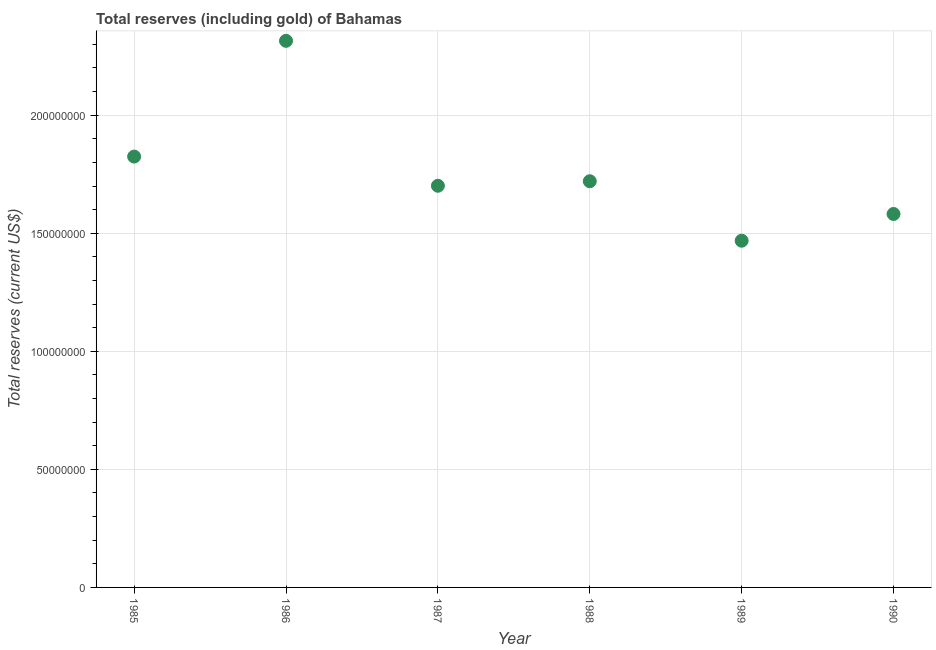What is the total reserves (including gold) in 1985?
Provide a short and direct response. 1.82e+08. Across all years, what is the maximum total reserves (including gold)?
Offer a terse response. 2.31e+08. Across all years, what is the minimum total reserves (including gold)?
Make the answer very short. 1.47e+08. In which year was the total reserves (including gold) maximum?
Give a very brief answer. 1986. In which year was the total reserves (including gold) minimum?
Your answer should be very brief. 1989. What is the sum of the total reserves (including gold)?
Your response must be concise. 1.06e+09. What is the difference between the total reserves (including gold) in 1985 and 1990?
Offer a terse response. 2.43e+07. What is the average total reserves (including gold) per year?
Your response must be concise. 1.77e+08. What is the median total reserves (including gold)?
Provide a succinct answer. 1.71e+08. In how many years, is the total reserves (including gold) greater than 190000000 US$?
Your answer should be very brief. 1. Do a majority of the years between 1986 and 1989 (inclusive) have total reserves (including gold) greater than 70000000 US$?
Your response must be concise. Yes. What is the ratio of the total reserves (including gold) in 1985 to that in 1988?
Give a very brief answer. 1.06. What is the difference between the highest and the second highest total reserves (including gold)?
Your response must be concise. 4.90e+07. What is the difference between the highest and the lowest total reserves (including gold)?
Offer a very short reply. 8.47e+07. In how many years, is the total reserves (including gold) greater than the average total reserves (including gold) taken over all years?
Provide a succinct answer. 2. How many years are there in the graph?
Keep it short and to the point. 6. Does the graph contain any zero values?
Your answer should be compact. No. What is the title of the graph?
Give a very brief answer. Total reserves (including gold) of Bahamas. What is the label or title of the Y-axis?
Keep it short and to the point. Total reserves (current US$). What is the Total reserves (current US$) in 1985?
Your answer should be very brief. 1.82e+08. What is the Total reserves (current US$) in 1986?
Your answer should be very brief. 2.31e+08. What is the Total reserves (current US$) in 1987?
Offer a very short reply. 1.70e+08. What is the Total reserves (current US$) in 1988?
Provide a succinct answer. 1.72e+08. What is the Total reserves (current US$) in 1989?
Keep it short and to the point. 1.47e+08. What is the Total reserves (current US$) in 1990?
Ensure brevity in your answer.  1.58e+08. What is the difference between the Total reserves (current US$) in 1985 and 1986?
Your answer should be compact. -4.90e+07. What is the difference between the Total reserves (current US$) in 1985 and 1987?
Your response must be concise. 1.24e+07. What is the difference between the Total reserves (current US$) in 1985 and 1988?
Your answer should be compact. 1.04e+07. What is the difference between the Total reserves (current US$) in 1985 and 1989?
Give a very brief answer. 3.56e+07. What is the difference between the Total reserves (current US$) in 1985 and 1990?
Make the answer very short. 2.43e+07. What is the difference between the Total reserves (current US$) in 1986 and 1987?
Your response must be concise. 6.14e+07. What is the difference between the Total reserves (current US$) in 1986 and 1988?
Your response must be concise. 5.95e+07. What is the difference between the Total reserves (current US$) in 1986 and 1989?
Offer a terse response. 8.47e+07. What is the difference between the Total reserves (current US$) in 1986 and 1990?
Ensure brevity in your answer.  7.33e+07. What is the difference between the Total reserves (current US$) in 1987 and 1988?
Make the answer very short. -1.92e+06. What is the difference between the Total reserves (current US$) in 1987 and 1989?
Keep it short and to the point. 2.33e+07. What is the difference between the Total reserves (current US$) in 1987 and 1990?
Your answer should be compact. 1.19e+07. What is the difference between the Total reserves (current US$) in 1988 and 1989?
Your answer should be very brief. 2.52e+07. What is the difference between the Total reserves (current US$) in 1988 and 1990?
Ensure brevity in your answer.  1.39e+07. What is the difference between the Total reserves (current US$) in 1989 and 1990?
Make the answer very short. -1.13e+07. What is the ratio of the Total reserves (current US$) in 1985 to that in 1986?
Ensure brevity in your answer.  0.79. What is the ratio of the Total reserves (current US$) in 1985 to that in 1987?
Offer a terse response. 1.07. What is the ratio of the Total reserves (current US$) in 1985 to that in 1988?
Your response must be concise. 1.06. What is the ratio of the Total reserves (current US$) in 1985 to that in 1989?
Provide a short and direct response. 1.24. What is the ratio of the Total reserves (current US$) in 1985 to that in 1990?
Your answer should be very brief. 1.15. What is the ratio of the Total reserves (current US$) in 1986 to that in 1987?
Offer a very short reply. 1.36. What is the ratio of the Total reserves (current US$) in 1986 to that in 1988?
Your answer should be very brief. 1.35. What is the ratio of the Total reserves (current US$) in 1986 to that in 1989?
Make the answer very short. 1.58. What is the ratio of the Total reserves (current US$) in 1986 to that in 1990?
Offer a terse response. 1.46. What is the ratio of the Total reserves (current US$) in 1987 to that in 1988?
Give a very brief answer. 0.99. What is the ratio of the Total reserves (current US$) in 1987 to that in 1989?
Provide a succinct answer. 1.16. What is the ratio of the Total reserves (current US$) in 1987 to that in 1990?
Your answer should be compact. 1.08. What is the ratio of the Total reserves (current US$) in 1988 to that in 1989?
Keep it short and to the point. 1.17. What is the ratio of the Total reserves (current US$) in 1988 to that in 1990?
Offer a very short reply. 1.09. What is the ratio of the Total reserves (current US$) in 1989 to that in 1990?
Ensure brevity in your answer.  0.93. 